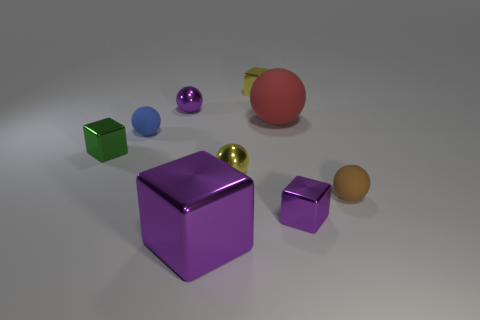Is the material of the tiny thing in front of the brown rubber ball the same as the large purple cube?
Your response must be concise. Yes. Are there any small shiny spheres in front of the blue thing?
Offer a very short reply. Yes. There is a tiny matte object behind the ball that is on the right side of the tiny purple shiny thing right of the tiny yellow sphere; what color is it?
Ensure brevity in your answer.  Blue. What shape is the green metallic thing that is the same size as the brown object?
Keep it short and to the point. Cube. Are there more tiny purple spheres than matte objects?
Your answer should be very brief. No. Is there a tiny brown object that is in front of the matte object left of the big cube?
Make the answer very short. Yes. The other tiny rubber object that is the same shape as the blue rubber thing is what color?
Your answer should be compact. Brown. Is there anything else that has the same shape as the small brown rubber object?
Your answer should be compact. Yes. What is the color of the other large thing that is the same material as the blue thing?
Your answer should be compact. Red. Is there a tiny thing right of the small purple thing that is in front of the small shiny cube that is left of the large purple cube?
Make the answer very short. Yes. 